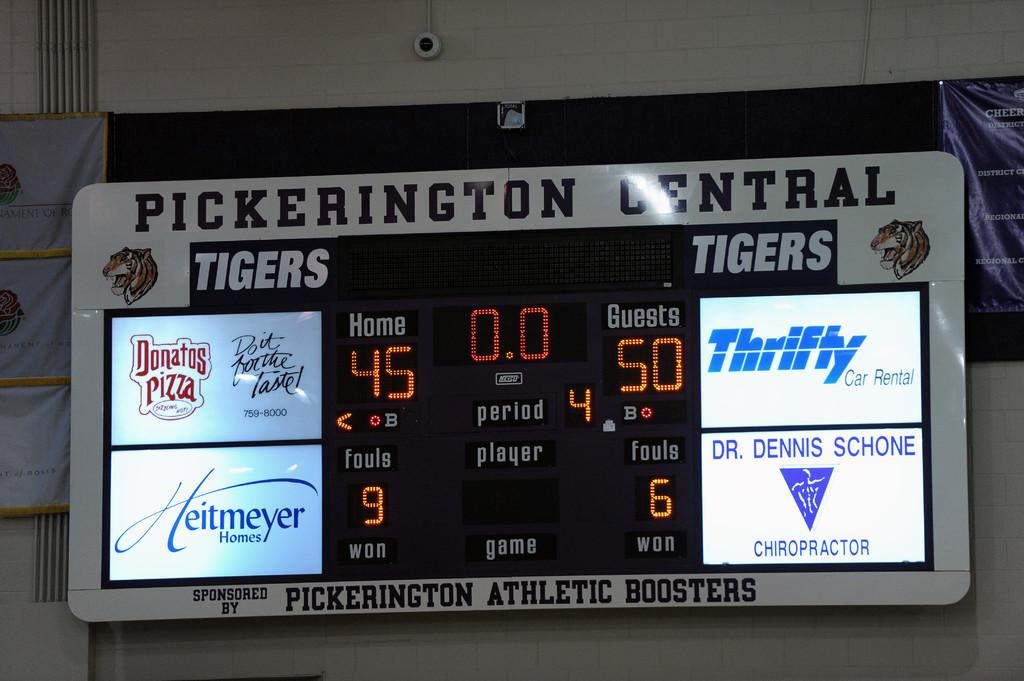Provide a one-sentence caption for the provided image. A scoreboard advertising Thrifty and Heitmeyer next to the scores. 